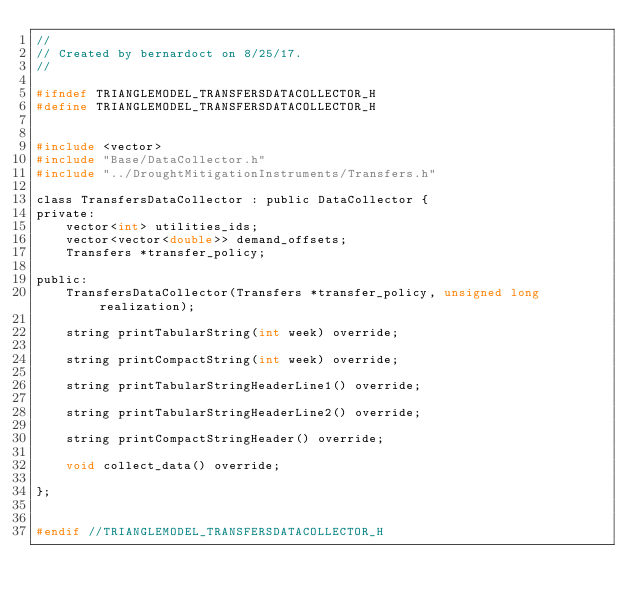Convert code to text. <code><loc_0><loc_0><loc_500><loc_500><_C_>//
// Created by bernardoct on 8/25/17.
//

#ifndef TRIANGLEMODEL_TRANSFERSDATACOLLECTOR_H
#define TRIANGLEMODEL_TRANSFERSDATACOLLECTOR_H


#include <vector>
#include "Base/DataCollector.h"
#include "../DroughtMitigationInstruments/Transfers.h"

class TransfersDataCollector : public DataCollector {
private:
    vector<int> utilities_ids;
    vector<vector<double>> demand_offsets;
    Transfers *transfer_policy;

public:
    TransfersDataCollector(Transfers *transfer_policy, unsigned long realization);

    string printTabularString(int week) override;

    string printCompactString(int week) override;

    string printTabularStringHeaderLine1() override;

    string printTabularStringHeaderLine2() override;

    string printCompactStringHeader() override;

    void collect_data() override;

};


#endif //TRIANGLEMODEL_TRANSFERSDATACOLLECTOR_H
</code> 